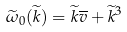<formula> <loc_0><loc_0><loc_500><loc_500>\widetilde { \omega } _ { 0 } ( \widetilde { k } ) = \widetilde { k } \overline { v } + \widetilde { k } ^ { 3 }</formula> 